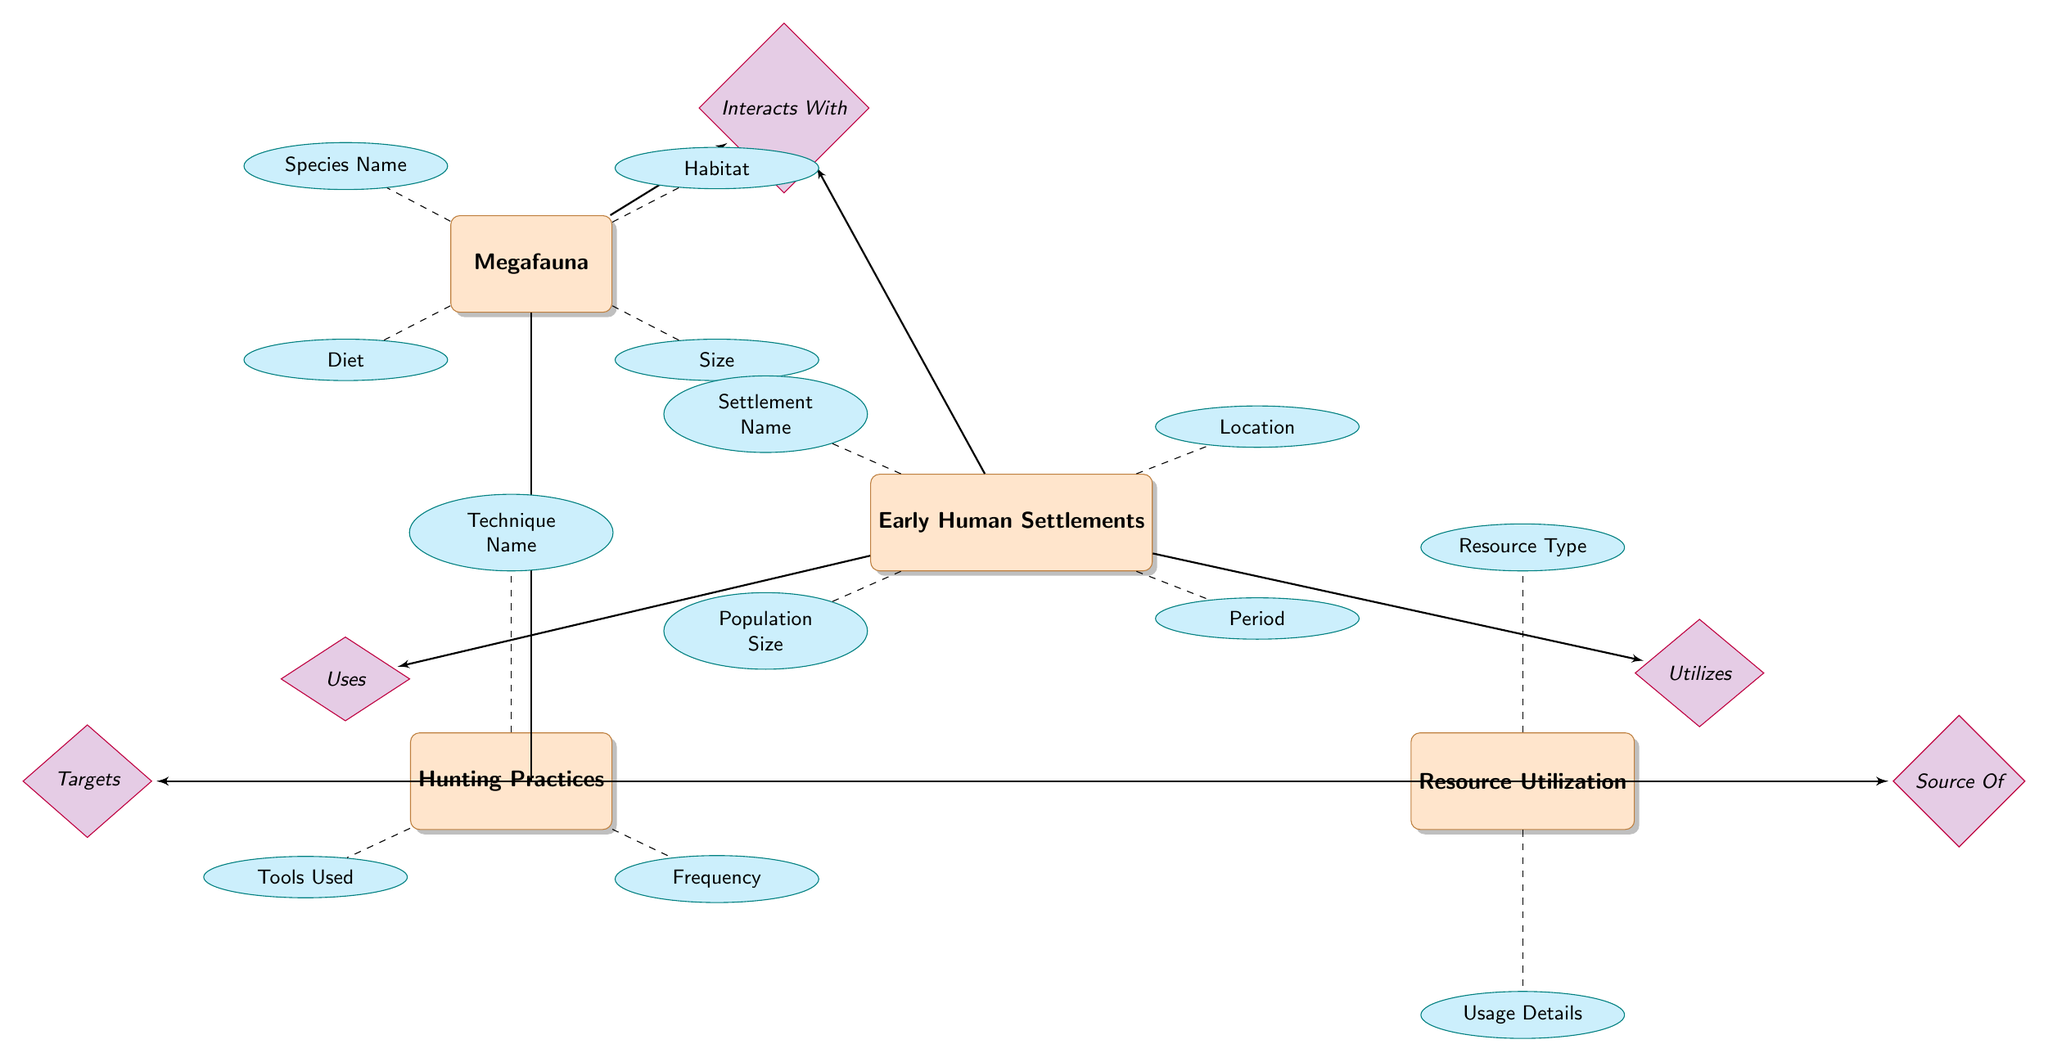What entity interacts with Megafauna? The diagram shows a relationship labeled "Interacts With" connecting Megafauna and Early Human Settlements. Therefore, the entity that interacts with Megafauna is Early Human Settlements.
Answer: Early Human Settlements How many attributes does Early Human Settlements have? By counting the attributes listed under the Early Human Settlements entity, we find there are four attributes: Settlement Name, Location, Population Size, and Period. Thus, the total number of attributes is four.
Answer: 4 What relationship type connects Hunting Practices to Early Human Settlements? The diagram specifies a relationship labeled "Used By" that connects Hunting Practices to Early Human Settlements. This indicates how Hunting Practices are associated with Early Human Settlements.
Answer: Used By Which entity is targeted by Hunting Practices? The diagram shows a relationship labeled "Targets" that directly connects Hunting Practices to Megafauna. This indicates that Megafauna is the entity targeted by Hunting Practices.
Answer: Megafauna What is the connection between Resource Utilization and Megafauna? According to the diagram, the relationship labeled "Source Of" links Resource Utilization to Megafauna. This means that Megafauna serves as a source for Resource Utilization activities in Early Human Settlements.
Answer: Source Of What is the attribute for Megafauna regarding its size? The diagram presents the attribute labeled "Size" under the Megafauna entity. This indicates that Size is one of the key characteristics used to describe Megafauna.
Answer: Size What does Early Human Settlements utilize? The diagram indicates a relationship labeled "Utilizes" that connects Early Human Settlements to Resource Utilization. This suggests that Early Human Settlements utilize the resources identified under Resource Utilization.
Answer: Resource Utilization How many entities are represented in the diagram? The diagram includes four entities: Megafauna, Early Human Settlements, Hunting Practices, and Resource Utilization. Counting these entities gives a total of four.
Answer: 4 What technique is associated with Hunting Practices? The attribute labeled "Technique Name" is listed under the Hunting Practices entity, which refers to the specific methods employed in hunting.
Answer: Technique Name 